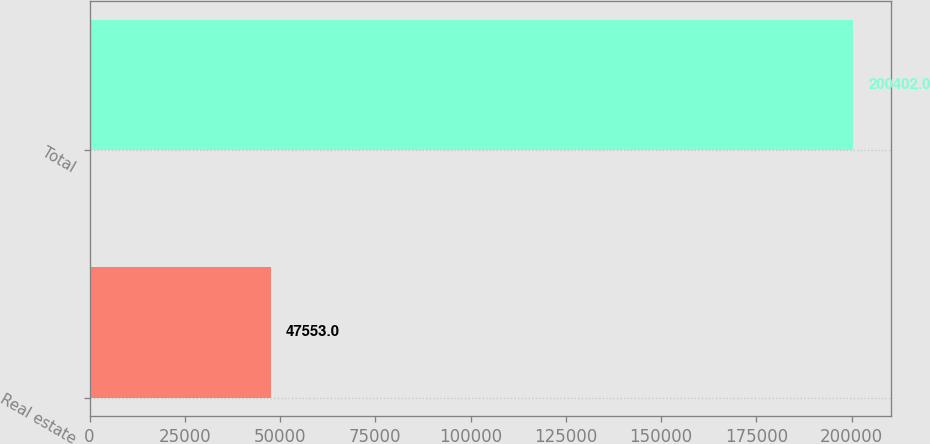<chart> <loc_0><loc_0><loc_500><loc_500><bar_chart><fcel>Real estate<fcel>Total<nl><fcel>47553<fcel>200402<nl></chart> 